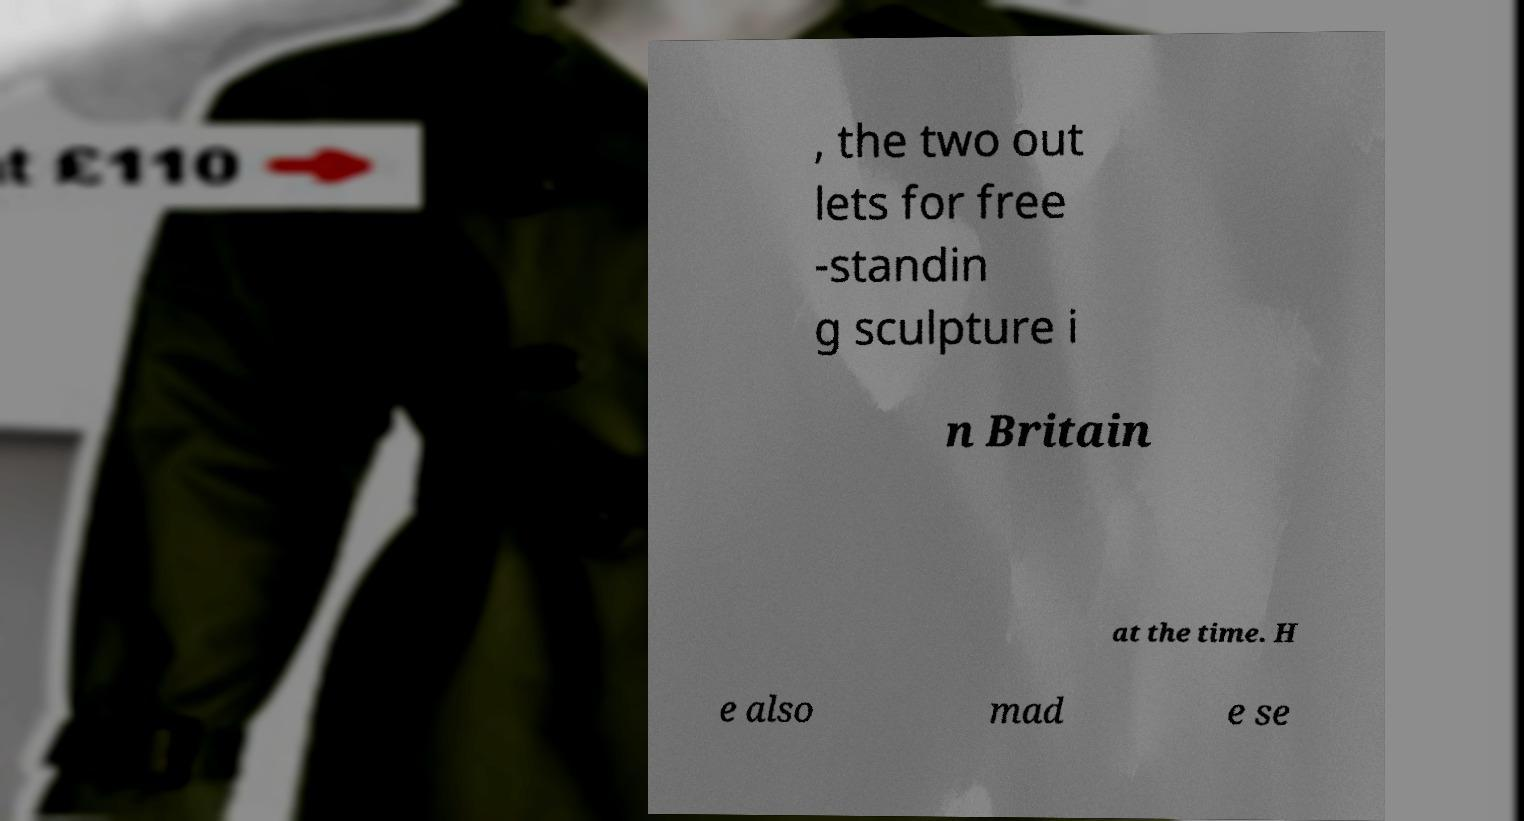For documentation purposes, I need the text within this image transcribed. Could you provide that? , the two out lets for free -standin g sculpture i n Britain at the time. H e also mad e se 